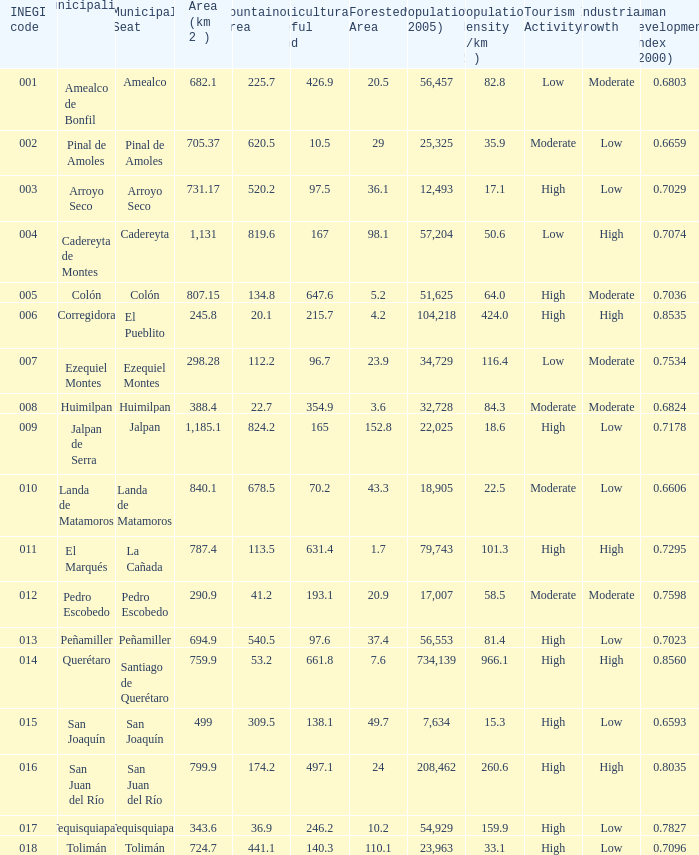Which Area (km 2 )has a Population (2005) of 57,204, and a Human Development Index (2000) smaller than 0.7074? 0.0. Write the full table. {'header': ['INEGI code', 'Municipality', 'Municipal Seat', 'Area (km 2 )', 'Mountainous Area', 'Agriculturally Useful Land', 'Forested Area', 'Population (2005)', 'Population density (/km 2 )', 'Tourism Activity', 'Industrial Growth', 'Human Development Index (2000)'], 'rows': [['001', 'Amealco de Bonfil', 'Amealco', '682.1', '225.7', '426.9', '20.5', '56,457', '82.8', 'Low', 'Moderate', '0.6803'], ['002', 'Pinal de Amoles', 'Pinal de Amoles', '705.37', '620.5', '10.5', '29', '25,325', '35.9', 'Moderate', 'Low', '0.6659'], ['003', 'Arroyo Seco', 'Arroyo Seco', '731.17', '520.2', '97.5', '36.1', '12,493', '17.1', 'High', 'Low', '0.7029'], ['004', 'Cadereyta de Montes', 'Cadereyta', '1,131', '819.6', '167', '98.1', '57,204', '50.6', 'Low', 'High', '0.7074'], ['005', 'Colón', 'Colón', '807.15', '134.8', '647.6', '5.2', '51,625', '64.0', 'High', 'Moderate', '0.7036'], ['006', 'Corregidora', 'El Pueblito', '245.8', '20.1', '215.7', '4.2', '104,218', '424.0', 'High', 'High', '0.8535'], ['007', 'Ezequiel Montes', 'Ezequiel Montes', '298.28', '112.2', '96.7', '23.9', '34,729', '116.4', 'Low', 'Moderate', '0.7534'], ['008', 'Huimilpan', 'Huimilpan', '388.4', '22.7', '354.9', '3.6', '32,728', '84.3', 'Moderate', 'Moderate', '0.6824'], ['009', 'Jalpan de Serra', 'Jalpan', '1,185.1', '824.2', '165', '152.8', '22,025', '18.6', 'High', 'Low', '0.7178'], ['010', 'Landa de Matamoros', 'Landa de Matamoros', '840.1', '678.5', '70.2', '43.3', '18,905', '22.5', 'Moderate', 'Low', '0.6606'], ['011', 'El Marqués', 'La Cañada', '787.4', '113.5', '631.4', '1.7', '79,743', '101.3', 'High', 'High', '0.7295'], ['012', 'Pedro Escobedo', 'Pedro Escobedo', '290.9', '41.2', '193.1', '20.9', '17,007', '58.5', 'Moderate', 'Moderate', '0.7598'], ['013', 'Peñamiller', 'Peñamiller', '694.9', '540.5', '97.6', '37.4', '56,553', '81.4', 'High', 'Low', '0.7023'], ['014', 'Querétaro', 'Santiago de Querétaro', '759.9', '53.2', '661.8', '7.6', '734,139', '966.1', 'High', 'High', '0.8560'], ['015', 'San Joaquín', 'San Joaquín', '499', '309.5', '138.1', '49.7', '7,634', '15.3', 'High', 'Low', '0.6593'], ['016', 'San Juan del Río', 'San Juan del Río', '799.9', '174.2', '497.1', '24', '208,462', '260.6', 'High', 'High', '0.8035'], ['017', 'Tequisquiapan', 'Tequisquiapan', '343.6', '36.9', '246.2', '10.2', '54,929', '159.9', 'High', 'Low', '0.7827'], ['018', 'Tolimán', 'Tolimán', '724.7', '441.1', '140.3', '110.1', '23,963', '33.1', 'High', 'Low', '0.7096']]} 